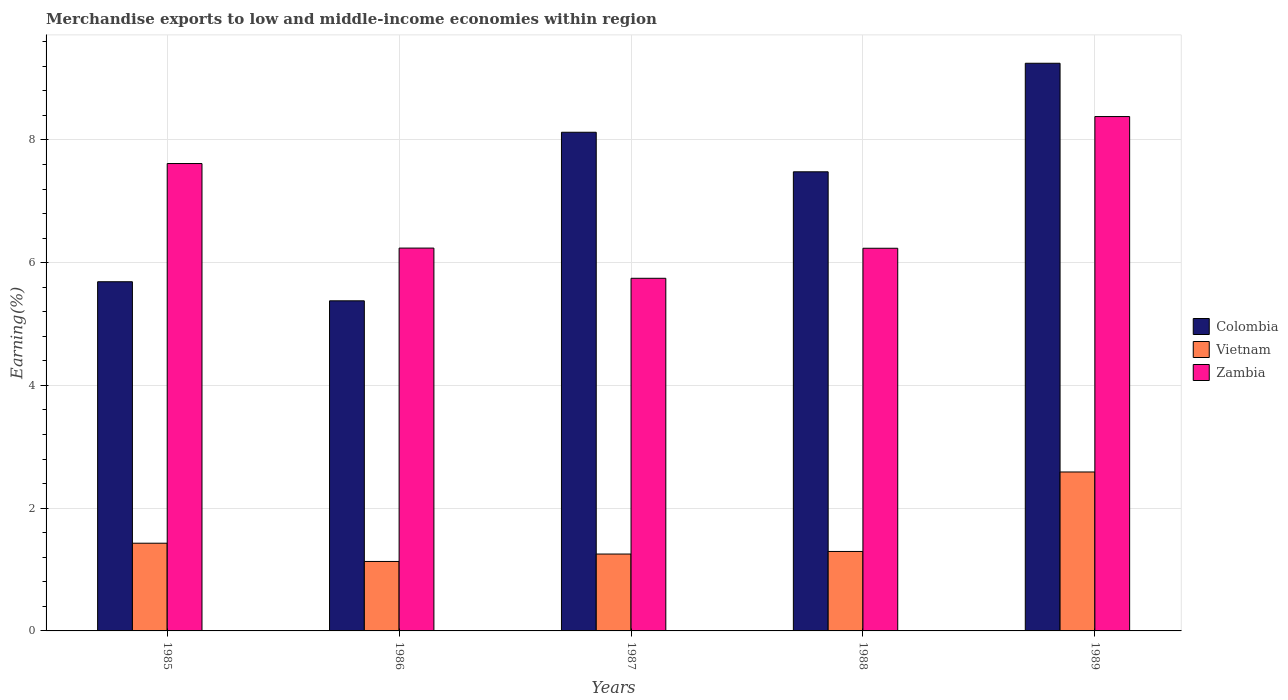How many groups of bars are there?
Offer a very short reply. 5. Are the number of bars per tick equal to the number of legend labels?
Your response must be concise. Yes. Are the number of bars on each tick of the X-axis equal?
Provide a succinct answer. Yes. How many bars are there on the 2nd tick from the left?
Give a very brief answer. 3. What is the percentage of amount earned from merchandise exports in Zambia in 1985?
Give a very brief answer. 7.62. Across all years, what is the maximum percentage of amount earned from merchandise exports in Colombia?
Offer a very short reply. 9.25. Across all years, what is the minimum percentage of amount earned from merchandise exports in Vietnam?
Ensure brevity in your answer.  1.13. In which year was the percentage of amount earned from merchandise exports in Zambia minimum?
Your answer should be compact. 1987. What is the total percentage of amount earned from merchandise exports in Colombia in the graph?
Your answer should be very brief. 35.92. What is the difference between the percentage of amount earned from merchandise exports in Colombia in 1986 and that in 1988?
Ensure brevity in your answer.  -2.1. What is the difference between the percentage of amount earned from merchandise exports in Zambia in 1987 and the percentage of amount earned from merchandise exports in Colombia in 1989?
Give a very brief answer. -3.5. What is the average percentage of amount earned from merchandise exports in Vietnam per year?
Keep it short and to the point. 1.54. In the year 1988, what is the difference between the percentage of amount earned from merchandise exports in Colombia and percentage of amount earned from merchandise exports in Vietnam?
Your answer should be compact. 6.19. In how many years, is the percentage of amount earned from merchandise exports in Vietnam greater than 2.4 %?
Make the answer very short. 1. What is the ratio of the percentage of amount earned from merchandise exports in Vietnam in 1985 to that in 1988?
Make the answer very short. 1.1. What is the difference between the highest and the second highest percentage of amount earned from merchandise exports in Vietnam?
Provide a short and direct response. 1.16. What is the difference between the highest and the lowest percentage of amount earned from merchandise exports in Colombia?
Ensure brevity in your answer.  3.87. In how many years, is the percentage of amount earned from merchandise exports in Vietnam greater than the average percentage of amount earned from merchandise exports in Vietnam taken over all years?
Offer a terse response. 1. What does the 2nd bar from the right in 1988 represents?
Provide a succinct answer. Vietnam. Is it the case that in every year, the sum of the percentage of amount earned from merchandise exports in Colombia and percentage of amount earned from merchandise exports in Zambia is greater than the percentage of amount earned from merchandise exports in Vietnam?
Provide a short and direct response. Yes. How many bars are there?
Keep it short and to the point. 15. Are all the bars in the graph horizontal?
Provide a succinct answer. No. Are the values on the major ticks of Y-axis written in scientific E-notation?
Keep it short and to the point. No. Does the graph contain grids?
Give a very brief answer. Yes. How are the legend labels stacked?
Offer a terse response. Vertical. What is the title of the graph?
Keep it short and to the point. Merchandise exports to low and middle-income economies within region. What is the label or title of the Y-axis?
Make the answer very short. Earning(%). What is the Earning(%) in Colombia in 1985?
Your answer should be compact. 5.69. What is the Earning(%) of Vietnam in 1985?
Offer a terse response. 1.43. What is the Earning(%) in Zambia in 1985?
Keep it short and to the point. 7.62. What is the Earning(%) of Colombia in 1986?
Make the answer very short. 5.38. What is the Earning(%) of Vietnam in 1986?
Make the answer very short. 1.13. What is the Earning(%) of Zambia in 1986?
Give a very brief answer. 6.24. What is the Earning(%) in Colombia in 1987?
Ensure brevity in your answer.  8.12. What is the Earning(%) in Vietnam in 1987?
Your answer should be very brief. 1.25. What is the Earning(%) in Zambia in 1987?
Offer a very short reply. 5.75. What is the Earning(%) in Colombia in 1988?
Ensure brevity in your answer.  7.48. What is the Earning(%) in Vietnam in 1988?
Provide a succinct answer. 1.29. What is the Earning(%) in Zambia in 1988?
Provide a short and direct response. 6.23. What is the Earning(%) of Colombia in 1989?
Your answer should be compact. 9.25. What is the Earning(%) in Vietnam in 1989?
Your answer should be compact. 2.59. What is the Earning(%) of Zambia in 1989?
Your answer should be compact. 8.38. Across all years, what is the maximum Earning(%) of Colombia?
Ensure brevity in your answer.  9.25. Across all years, what is the maximum Earning(%) in Vietnam?
Offer a very short reply. 2.59. Across all years, what is the maximum Earning(%) in Zambia?
Offer a very short reply. 8.38. Across all years, what is the minimum Earning(%) of Colombia?
Ensure brevity in your answer.  5.38. Across all years, what is the minimum Earning(%) of Vietnam?
Your response must be concise. 1.13. Across all years, what is the minimum Earning(%) of Zambia?
Your answer should be compact. 5.75. What is the total Earning(%) of Colombia in the graph?
Keep it short and to the point. 35.92. What is the total Earning(%) of Vietnam in the graph?
Your response must be concise. 7.7. What is the total Earning(%) in Zambia in the graph?
Make the answer very short. 34.21. What is the difference between the Earning(%) of Colombia in 1985 and that in 1986?
Offer a very short reply. 0.31. What is the difference between the Earning(%) in Vietnam in 1985 and that in 1986?
Your response must be concise. 0.3. What is the difference between the Earning(%) of Zambia in 1985 and that in 1986?
Keep it short and to the point. 1.38. What is the difference between the Earning(%) of Colombia in 1985 and that in 1987?
Offer a very short reply. -2.44. What is the difference between the Earning(%) in Vietnam in 1985 and that in 1987?
Keep it short and to the point. 0.18. What is the difference between the Earning(%) in Zambia in 1985 and that in 1987?
Offer a terse response. 1.87. What is the difference between the Earning(%) of Colombia in 1985 and that in 1988?
Keep it short and to the point. -1.79. What is the difference between the Earning(%) of Vietnam in 1985 and that in 1988?
Your answer should be very brief. 0.13. What is the difference between the Earning(%) in Zambia in 1985 and that in 1988?
Your response must be concise. 1.38. What is the difference between the Earning(%) in Colombia in 1985 and that in 1989?
Your answer should be very brief. -3.56. What is the difference between the Earning(%) in Vietnam in 1985 and that in 1989?
Your answer should be very brief. -1.16. What is the difference between the Earning(%) in Zambia in 1985 and that in 1989?
Your answer should be very brief. -0.77. What is the difference between the Earning(%) in Colombia in 1986 and that in 1987?
Offer a very short reply. -2.75. What is the difference between the Earning(%) in Vietnam in 1986 and that in 1987?
Make the answer very short. -0.12. What is the difference between the Earning(%) in Zambia in 1986 and that in 1987?
Offer a terse response. 0.49. What is the difference between the Earning(%) in Colombia in 1986 and that in 1988?
Offer a very short reply. -2.1. What is the difference between the Earning(%) in Vietnam in 1986 and that in 1988?
Ensure brevity in your answer.  -0.16. What is the difference between the Earning(%) of Zambia in 1986 and that in 1988?
Provide a short and direct response. 0. What is the difference between the Earning(%) of Colombia in 1986 and that in 1989?
Provide a succinct answer. -3.87. What is the difference between the Earning(%) of Vietnam in 1986 and that in 1989?
Ensure brevity in your answer.  -1.46. What is the difference between the Earning(%) in Zambia in 1986 and that in 1989?
Provide a short and direct response. -2.14. What is the difference between the Earning(%) of Colombia in 1987 and that in 1988?
Your answer should be very brief. 0.64. What is the difference between the Earning(%) of Vietnam in 1987 and that in 1988?
Your response must be concise. -0.04. What is the difference between the Earning(%) in Zambia in 1987 and that in 1988?
Provide a short and direct response. -0.49. What is the difference between the Earning(%) in Colombia in 1987 and that in 1989?
Make the answer very short. -1.12. What is the difference between the Earning(%) of Vietnam in 1987 and that in 1989?
Your answer should be compact. -1.34. What is the difference between the Earning(%) of Zambia in 1987 and that in 1989?
Ensure brevity in your answer.  -2.64. What is the difference between the Earning(%) of Colombia in 1988 and that in 1989?
Offer a terse response. -1.77. What is the difference between the Earning(%) of Vietnam in 1988 and that in 1989?
Give a very brief answer. -1.3. What is the difference between the Earning(%) of Zambia in 1988 and that in 1989?
Your response must be concise. -2.15. What is the difference between the Earning(%) of Colombia in 1985 and the Earning(%) of Vietnam in 1986?
Your answer should be compact. 4.56. What is the difference between the Earning(%) in Colombia in 1985 and the Earning(%) in Zambia in 1986?
Your answer should be very brief. -0.55. What is the difference between the Earning(%) in Vietnam in 1985 and the Earning(%) in Zambia in 1986?
Give a very brief answer. -4.81. What is the difference between the Earning(%) in Colombia in 1985 and the Earning(%) in Vietnam in 1987?
Ensure brevity in your answer.  4.44. What is the difference between the Earning(%) in Colombia in 1985 and the Earning(%) in Zambia in 1987?
Offer a very short reply. -0.06. What is the difference between the Earning(%) in Vietnam in 1985 and the Earning(%) in Zambia in 1987?
Provide a succinct answer. -4.32. What is the difference between the Earning(%) in Colombia in 1985 and the Earning(%) in Vietnam in 1988?
Provide a succinct answer. 4.39. What is the difference between the Earning(%) in Colombia in 1985 and the Earning(%) in Zambia in 1988?
Provide a succinct answer. -0.55. What is the difference between the Earning(%) of Vietnam in 1985 and the Earning(%) of Zambia in 1988?
Offer a terse response. -4.81. What is the difference between the Earning(%) of Colombia in 1985 and the Earning(%) of Vietnam in 1989?
Make the answer very short. 3.1. What is the difference between the Earning(%) in Colombia in 1985 and the Earning(%) in Zambia in 1989?
Your response must be concise. -2.69. What is the difference between the Earning(%) in Vietnam in 1985 and the Earning(%) in Zambia in 1989?
Make the answer very short. -6.95. What is the difference between the Earning(%) in Colombia in 1986 and the Earning(%) in Vietnam in 1987?
Keep it short and to the point. 4.13. What is the difference between the Earning(%) in Colombia in 1986 and the Earning(%) in Zambia in 1987?
Offer a very short reply. -0.37. What is the difference between the Earning(%) of Vietnam in 1986 and the Earning(%) of Zambia in 1987?
Your answer should be very brief. -4.61. What is the difference between the Earning(%) of Colombia in 1986 and the Earning(%) of Vietnam in 1988?
Give a very brief answer. 4.08. What is the difference between the Earning(%) of Colombia in 1986 and the Earning(%) of Zambia in 1988?
Keep it short and to the point. -0.86. What is the difference between the Earning(%) of Vietnam in 1986 and the Earning(%) of Zambia in 1988?
Offer a terse response. -5.1. What is the difference between the Earning(%) of Colombia in 1986 and the Earning(%) of Vietnam in 1989?
Provide a short and direct response. 2.79. What is the difference between the Earning(%) of Colombia in 1986 and the Earning(%) of Zambia in 1989?
Ensure brevity in your answer.  -3. What is the difference between the Earning(%) of Vietnam in 1986 and the Earning(%) of Zambia in 1989?
Give a very brief answer. -7.25. What is the difference between the Earning(%) in Colombia in 1987 and the Earning(%) in Vietnam in 1988?
Make the answer very short. 6.83. What is the difference between the Earning(%) of Colombia in 1987 and the Earning(%) of Zambia in 1988?
Keep it short and to the point. 1.89. What is the difference between the Earning(%) of Vietnam in 1987 and the Earning(%) of Zambia in 1988?
Provide a succinct answer. -4.98. What is the difference between the Earning(%) in Colombia in 1987 and the Earning(%) in Vietnam in 1989?
Your answer should be very brief. 5.54. What is the difference between the Earning(%) in Colombia in 1987 and the Earning(%) in Zambia in 1989?
Give a very brief answer. -0.26. What is the difference between the Earning(%) of Vietnam in 1987 and the Earning(%) of Zambia in 1989?
Your answer should be compact. -7.13. What is the difference between the Earning(%) in Colombia in 1988 and the Earning(%) in Vietnam in 1989?
Provide a short and direct response. 4.89. What is the difference between the Earning(%) of Colombia in 1988 and the Earning(%) of Zambia in 1989?
Your response must be concise. -0.9. What is the difference between the Earning(%) of Vietnam in 1988 and the Earning(%) of Zambia in 1989?
Give a very brief answer. -7.09. What is the average Earning(%) in Colombia per year?
Your answer should be very brief. 7.18. What is the average Earning(%) in Vietnam per year?
Ensure brevity in your answer.  1.54. What is the average Earning(%) of Zambia per year?
Provide a short and direct response. 6.84. In the year 1985, what is the difference between the Earning(%) of Colombia and Earning(%) of Vietnam?
Provide a short and direct response. 4.26. In the year 1985, what is the difference between the Earning(%) of Colombia and Earning(%) of Zambia?
Give a very brief answer. -1.93. In the year 1985, what is the difference between the Earning(%) of Vietnam and Earning(%) of Zambia?
Make the answer very short. -6.19. In the year 1986, what is the difference between the Earning(%) of Colombia and Earning(%) of Vietnam?
Your answer should be very brief. 4.25. In the year 1986, what is the difference between the Earning(%) of Colombia and Earning(%) of Zambia?
Provide a short and direct response. -0.86. In the year 1986, what is the difference between the Earning(%) in Vietnam and Earning(%) in Zambia?
Offer a terse response. -5.11. In the year 1987, what is the difference between the Earning(%) in Colombia and Earning(%) in Vietnam?
Your answer should be very brief. 6.87. In the year 1987, what is the difference between the Earning(%) in Colombia and Earning(%) in Zambia?
Provide a short and direct response. 2.38. In the year 1987, what is the difference between the Earning(%) of Vietnam and Earning(%) of Zambia?
Ensure brevity in your answer.  -4.49. In the year 1988, what is the difference between the Earning(%) in Colombia and Earning(%) in Vietnam?
Provide a short and direct response. 6.19. In the year 1988, what is the difference between the Earning(%) of Colombia and Earning(%) of Zambia?
Provide a short and direct response. 1.25. In the year 1988, what is the difference between the Earning(%) in Vietnam and Earning(%) in Zambia?
Provide a short and direct response. -4.94. In the year 1989, what is the difference between the Earning(%) of Colombia and Earning(%) of Vietnam?
Provide a short and direct response. 6.66. In the year 1989, what is the difference between the Earning(%) of Colombia and Earning(%) of Zambia?
Ensure brevity in your answer.  0.87. In the year 1989, what is the difference between the Earning(%) in Vietnam and Earning(%) in Zambia?
Make the answer very short. -5.79. What is the ratio of the Earning(%) of Colombia in 1985 to that in 1986?
Provide a succinct answer. 1.06. What is the ratio of the Earning(%) in Vietnam in 1985 to that in 1986?
Your response must be concise. 1.26. What is the ratio of the Earning(%) in Zambia in 1985 to that in 1986?
Make the answer very short. 1.22. What is the ratio of the Earning(%) of Colombia in 1985 to that in 1987?
Offer a very short reply. 0.7. What is the ratio of the Earning(%) in Vietnam in 1985 to that in 1987?
Make the answer very short. 1.14. What is the ratio of the Earning(%) of Zambia in 1985 to that in 1987?
Offer a terse response. 1.33. What is the ratio of the Earning(%) in Colombia in 1985 to that in 1988?
Keep it short and to the point. 0.76. What is the ratio of the Earning(%) in Vietnam in 1985 to that in 1988?
Offer a very short reply. 1.1. What is the ratio of the Earning(%) of Zambia in 1985 to that in 1988?
Offer a terse response. 1.22. What is the ratio of the Earning(%) in Colombia in 1985 to that in 1989?
Provide a succinct answer. 0.62. What is the ratio of the Earning(%) of Vietnam in 1985 to that in 1989?
Your answer should be very brief. 0.55. What is the ratio of the Earning(%) in Zambia in 1985 to that in 1989?
Provide a succinct answer. 0.91. What is the ratio of the Earning(%) in Colombia in 1986 to that in 1987?
Offer a very short reply. 0.66. What is the ratio of the Earning(%) in Vietnam in 1986 to that in 1987?
Provide a short and direct response. 0.9. What is the ratio of the Earning(%) in Zambia in 1986 to that in 1987?
Make the answer very short. 1.09. What is the ratio of the Earning(%) of Colombia in 1986 to that in 1988?
Ensure brevity in your answer.  0.72. What is the ratio of the Earning(%) in Vietnam in 1986 to that in 1988?
Your response must be concise. 0.87. What is the ratio of the Earning(%) of Colombia in 1986 to that in 1989?
Give a very brief answer. 0.58. What is the ratio of the Earning(%) of Vietnam in 1986 to that in 1989?
Your answer should be compact. 0.44. What is the ratio of the Earning(%) of Zambia in 1986 to that in 1989?
Keep it short and to the point. 0.74. What is the ratio of the Earning(%) in Colombia in 1987 to that in 1988?
Provide a succinct answer. 1.09. What is the ratio of the Earning(%) of Vietnam in 1987 to that in 1988?
Offer a very short reply. 0.97. What is the ratio of the Earning(%) of Zambia in 1987 to that in 1988?
Provide a short and direct response. 0.92. What is the ratio of the Earning(%) of Colombia in 1987 to that in 1989?
Provide a short and direct response. 0.88. What is the ratio of the Earning(%) of Vietnam in 1987 to that in 1989?
Make the answer very short. 0.48. What is the ratio of the Earning(%) in Zambia in 1987 to that in 1989?
Your answer should be very brief. 0.69. What is the ratio of the Earning(%) in Colombia in 1988 to that in 1989?
Keep it short and to the point. 0.81. What is the ratio of the Earning(%) in Vietnam in 1988 to that in 1989?
Offer a very short reply. 0.5. What is the ratio of the Earning(%) of Zambia in 1988 to that in 1989?
Ensure brevity in your answer.  0.74. What is the difference between the highest and the second highest Earning(%) of Colombia?
Provide a short and direct response. 1.12. What is the difference between the highest and the second highest Earning(%) in Vietnam?
Provide a succinct answer. 1.16. What is the difference between the highest and the second highest Earning(%) in Zambia?
Make the answer very short. 0.77. What is the difference between the highest and the lowest Earning(%) of Colombia?
Give a very brief answer. 3.87. What is the difference between the highest and the lowest Earning(%) of Vietnam?
Your answer should be compact. 1.46. What is the difference between the highest and the lowest Earning(%) of Zambia?
Your response must be concise. 2.64. 